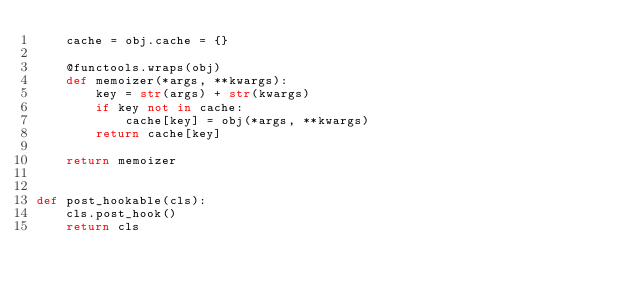Convert code to text. <code><loc_0><loc_0><loc_500><loc_500><_Python_>    cache = obj.cache = {}

    @functools.wraps(obj)
    def memoizer(*args, **kwargs):
        key = str(args) + str(kwargs)
        if key not in cache:
            cache[key] = obj(*args, **kwargs)
        return cache[key]

    return memoizer


def post_hookable(cls):
    cls.post_hook()
    return cls</code> 